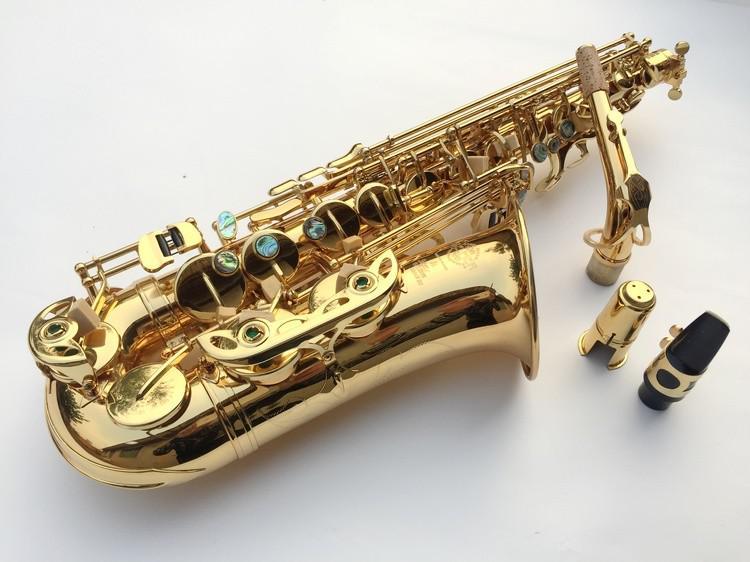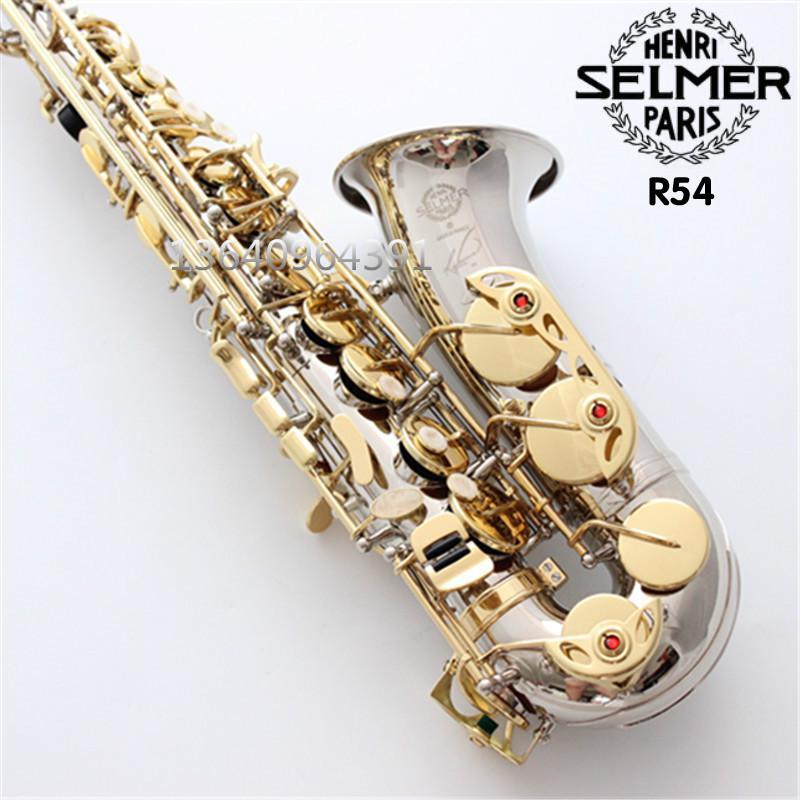The first image is the image on the left, the second image is the image on the right. Evaluate the accuracy of this statement regarding the images: "A mouthpiece with a black tip is next to a gold-colored saxophone in one image.". Is it true? Answer yes or no. Yes. The first image is the image on the left, the second image is the image on the right. Considering the images on both sides, is "At least one of the images shows a booklet next to the instrument." valid? Answer yes or no. No. 